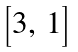<formula> <loc_0><loc_0><loc_500><loc_500>\begin{bmatrix} 3 , \, 1 \end{bmatrix}</formula> 